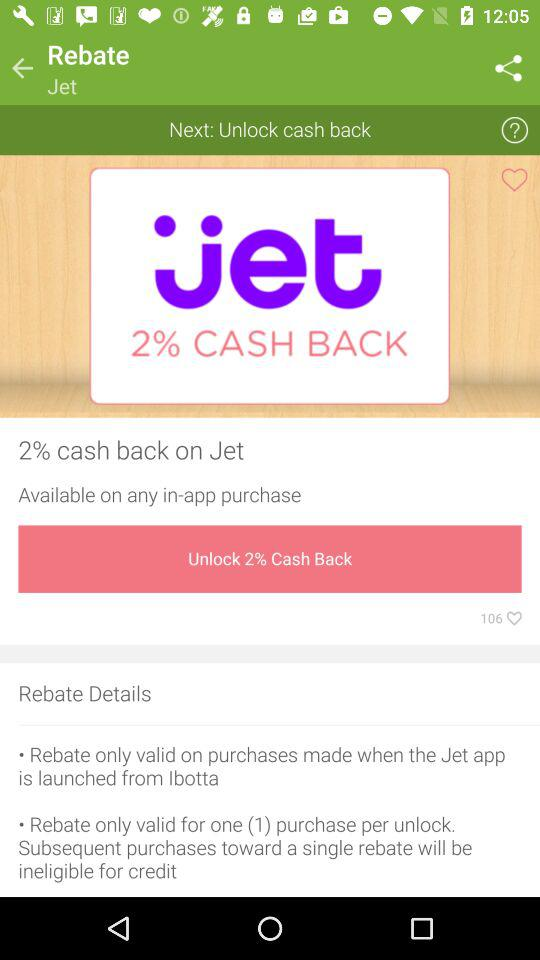How many percent cash back is offered on Jet?
Answer the question using a single word or phrase. 2% 